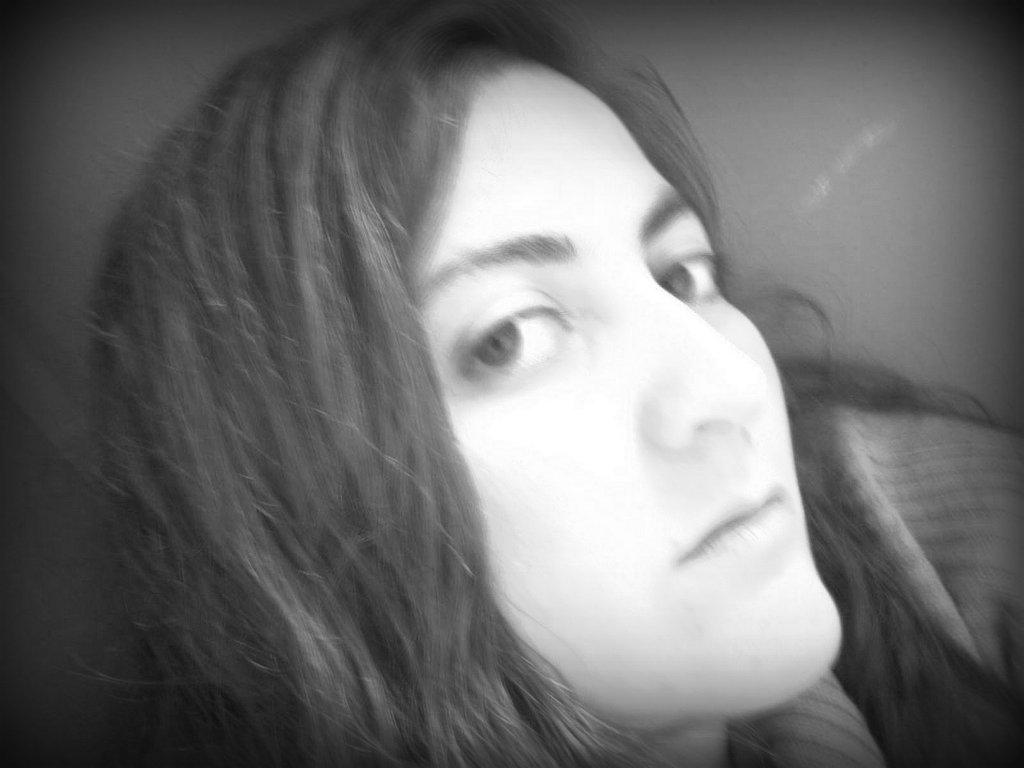What is the main subject of the image? The main subject of the image is a woman's face. What color scheme is used in the image? The image is black and white. How many boats are visible in the image? There are no boats present in the image. What type of birthday celebration is depicted in the image? There is no birthday celebration depicted in the image; it features a woman's face in black and white. 